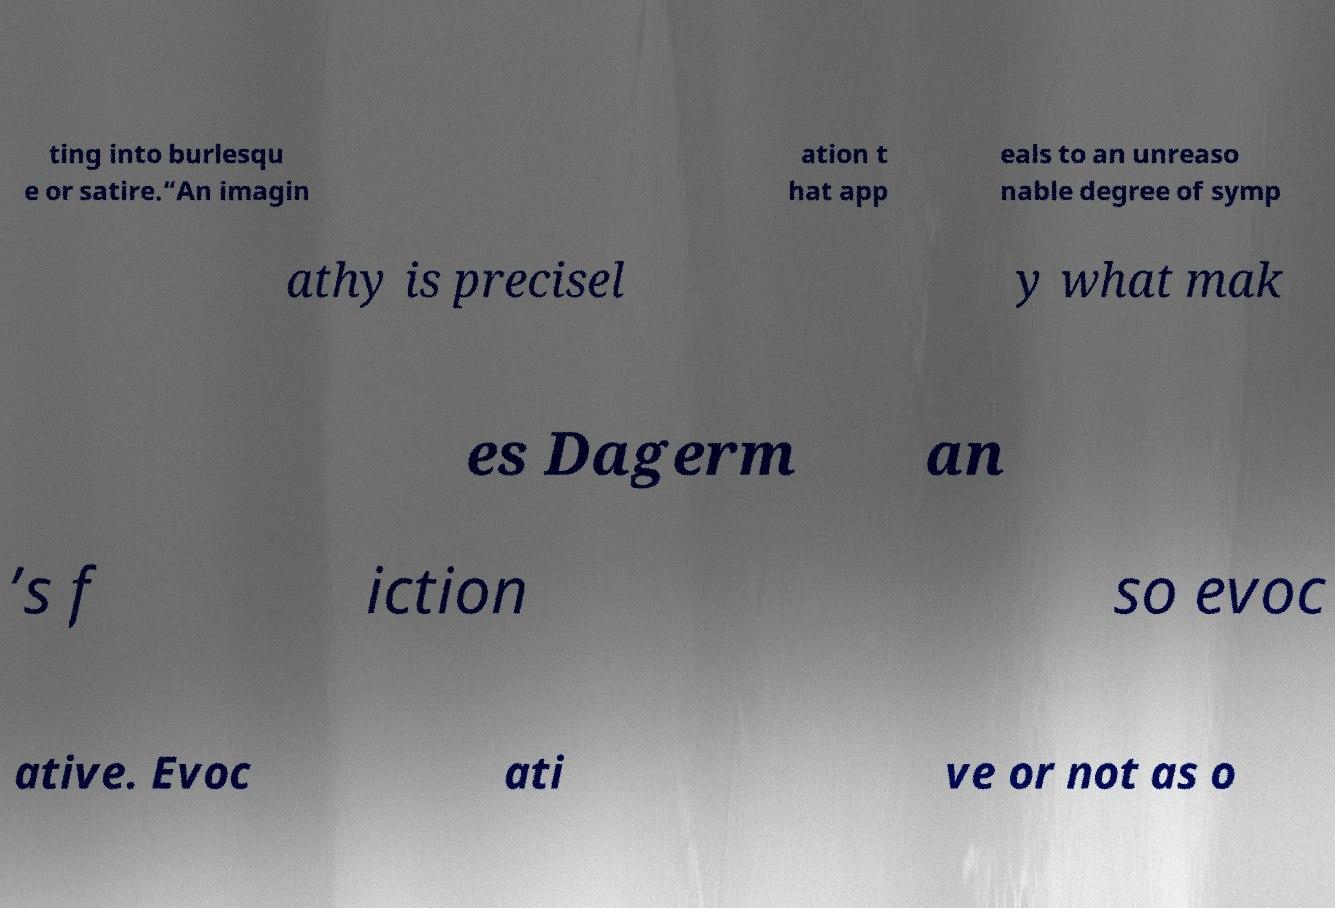Could you extract and type out the text from this image? ting into burlesqu e or satire.“An imagin ation t hat app eals to an unreaso nable degree of symp athy is precisel y what mak es Dagerm an ’s f iction so evoc ative. Evoc ati ve or not as o 